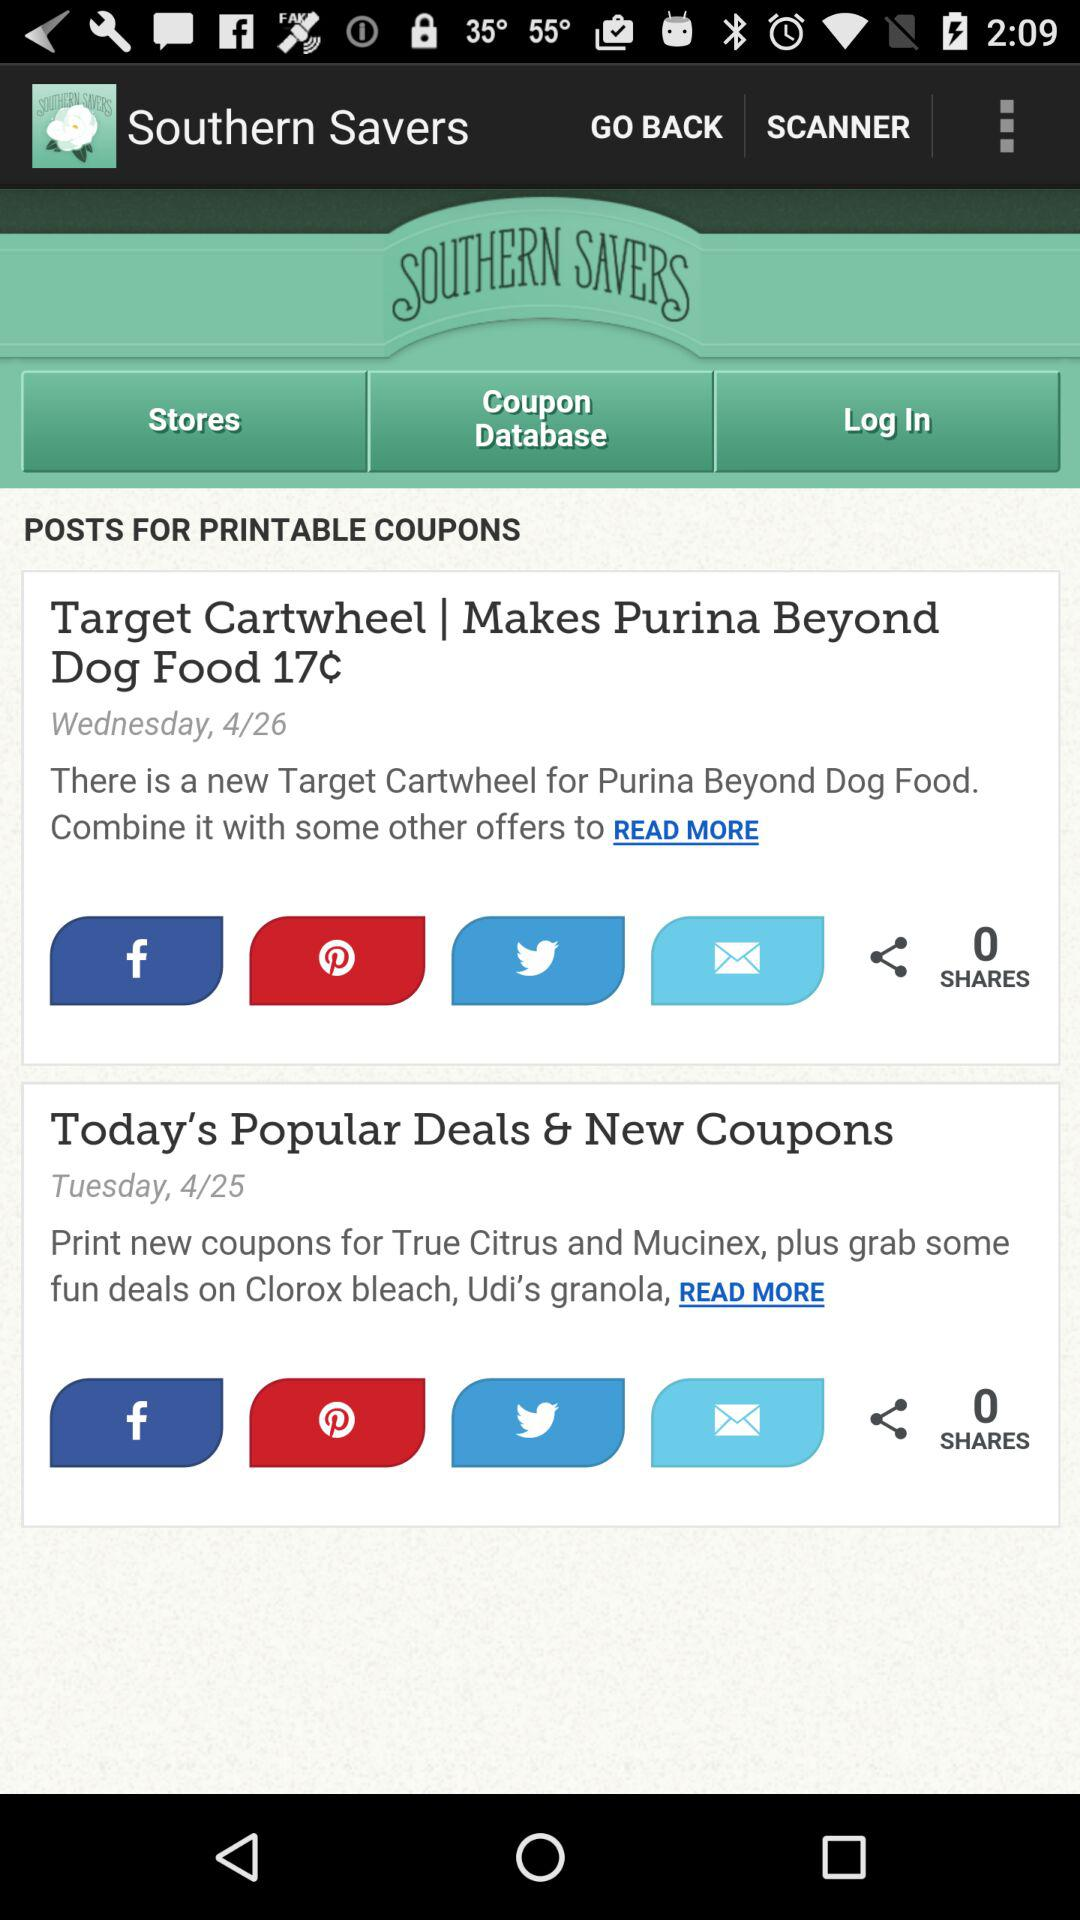What is the posted date of "Target Cartwheel"? The posted date of "Target Cartwheel" is Wednesday, April 26. 